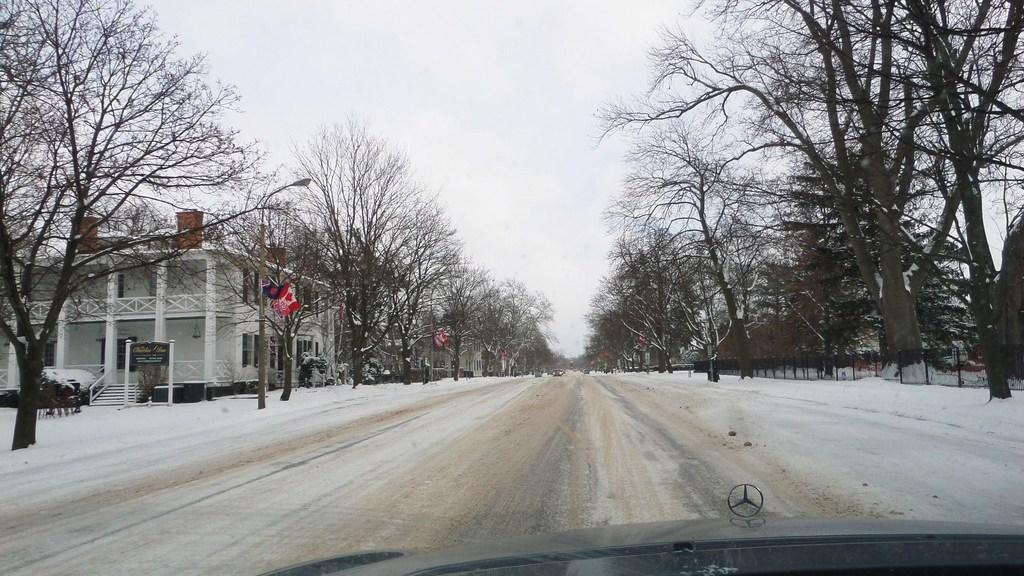What can be seen on the road in the image? There are vehicles on the road in the image. What type of natural elements are present in the image? There are trees in the image. What structures can be seen in the image? There are boards, pillars, a fence, buildings, and light poles in the image. What is the group of people doing in the image? The group of people is not specified, but they are present in the image. What additional elements are visible in the image? There are flags in the image. What part of the environment is visible in the image? The sky is visible in the image, and it is likely taken during the day. Where is the playground located in the image? There is no playground present in the image. Who is the judge standing next to in the image? There is no judge present in the image. 